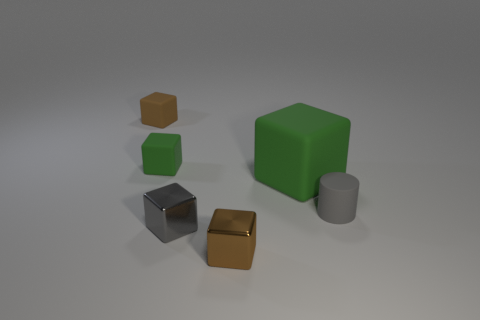Are there any small rubber objects that have the same color as the big matte thing?
Your answer should be very brief. Yes. What number of things are either brown metal objects in front of the big green thing or small matte things behind the tiny green cube?
Ensure brevity in your answer.  2. There is a brown thing to the right of the small green matte thing; is there a tiny gray thing that is to the left of it?
Your answer should be very brief. Yes. What is the shape of the gray rubber thing that is the same size as the gray cube?
Keep it short and to the point. Cylinder. What number of things are either tiny matte cubes in front of the small brown rubber block or tiny metal things?
Your response must be concise. 3. What number of other objects are the same material as the big block?
Keep it short and to the point. 3. What shape is the rubber object that is the same color as the large matte cube?
Make the answer very short. Cube. How big is the green object in front of the small green rubber cube?
Keep it short and to the point. Large. What is the shape of the large thing that is made of the same material as the tiny gray cylinder?
Provide a short and direct response. Cube. Are the small green thing and the gray thing that is right of the big green matte thing made of the same material?
Give a very brief answer. Yes. 